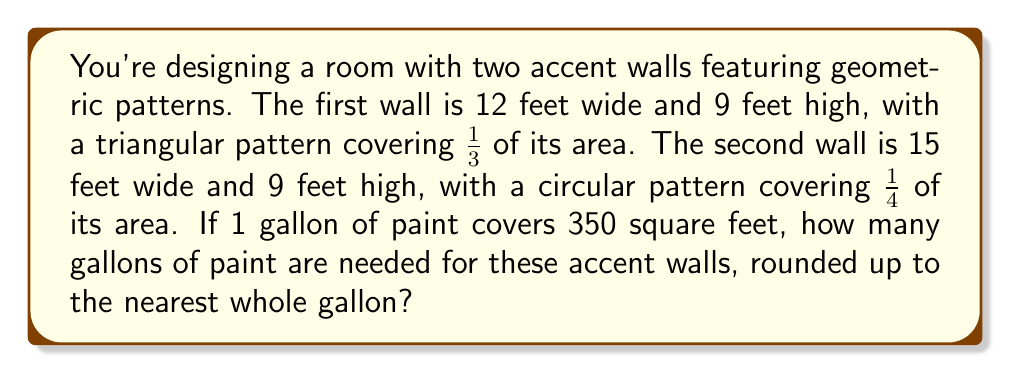Give your solution to this math problem. Let's break this down step-by-step:

1. Calculate the total area of the first wall:
   $A_1 = 12 \text{ ft} \times 9 \text{ ft} = 108 \text{ sq ft}$

2. Calculate the area to be painted on the first wall (2/3 of the total area):
   $A_{1p} = \frac{2}{3} \times 108 \text{ sq ft} = 72 \text{ sq ft}$

3. Calculate the total area of the second wall:
   $A_2 = 15 \text{ ft} \times 9 \text{ ft} = 135 \text{ sq ft}$

4. Calculate the area to be painted on the second wall (3/4 of the total area):
   $A_{2p} = \frac{3}{4} \times 135 \text{ sq ft} = 101.25 \text{ sq ft}$

5. Sum up the total area to be painted:
   $A_{total} = A_{1p} + A_{2p} = 72 \text{ sq ft} + 101.25 \text{ sq ft} = 173.25 \text{ sq ft}$

6. Calculate the number of gallons needed:
   $$\text{Gallons} = \frac{A_{total}}{350 \text{ sq ft/gallon}} = \frac{173.25 \text{ sq ft}}{350 \text{ sq ft/gallon}} \approx 0.495 \text{ gallons}$$

7. Round up to the nearest whole gallon:
   0.495 gallons rounds up to 1 gallon
Answer: 1 gallon 